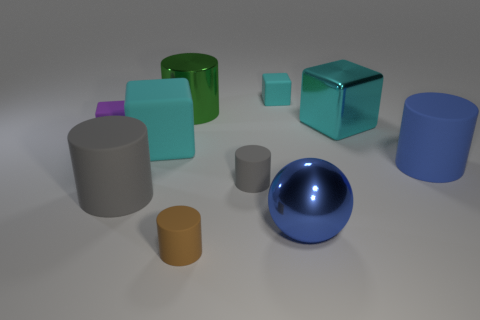There is a object that is both behind the small brown thing and in front of the large gray matte thing; what is its shape?
Ensure brevity in your answer.  Sphere. What number of other things are there of the same color as the large matte cube?
Offer a terse response. 2. How many things are either rubber cubes to the right of the brown matte cylinder or tiny red matte cubes?
Offer a terse response. 1. Does the large shiny ball have the same color as the tiny matte object in front of the large blue ball?
Keep it short and to the point. No. Is there any other thing that is the same size as the purple block?
Offer a terse response. Yes. There is a cyan matte block that is on the right side of the gray cylinder to the right of the green object; how big is it?
Provide a succinct answer. Small. What number of things are shiny cylinders or cyan matte cubes to the left of the large blue metal thing?
Offer a very short reply. 3. There is a shiny thing that is in front of the big blue cylinder; is it the same shape as the blue matte thing?
Keep it short and to the point. No. There is a large metallic block that is behind the cyan cube on the left side of the small cyan rubber thing; what number of rubber cubes are on the left side of it?
Ensure brevity in your answer.  3. Is there any other thing that is the same shape as the purple object?
Provide a short and direct response. Yes. 